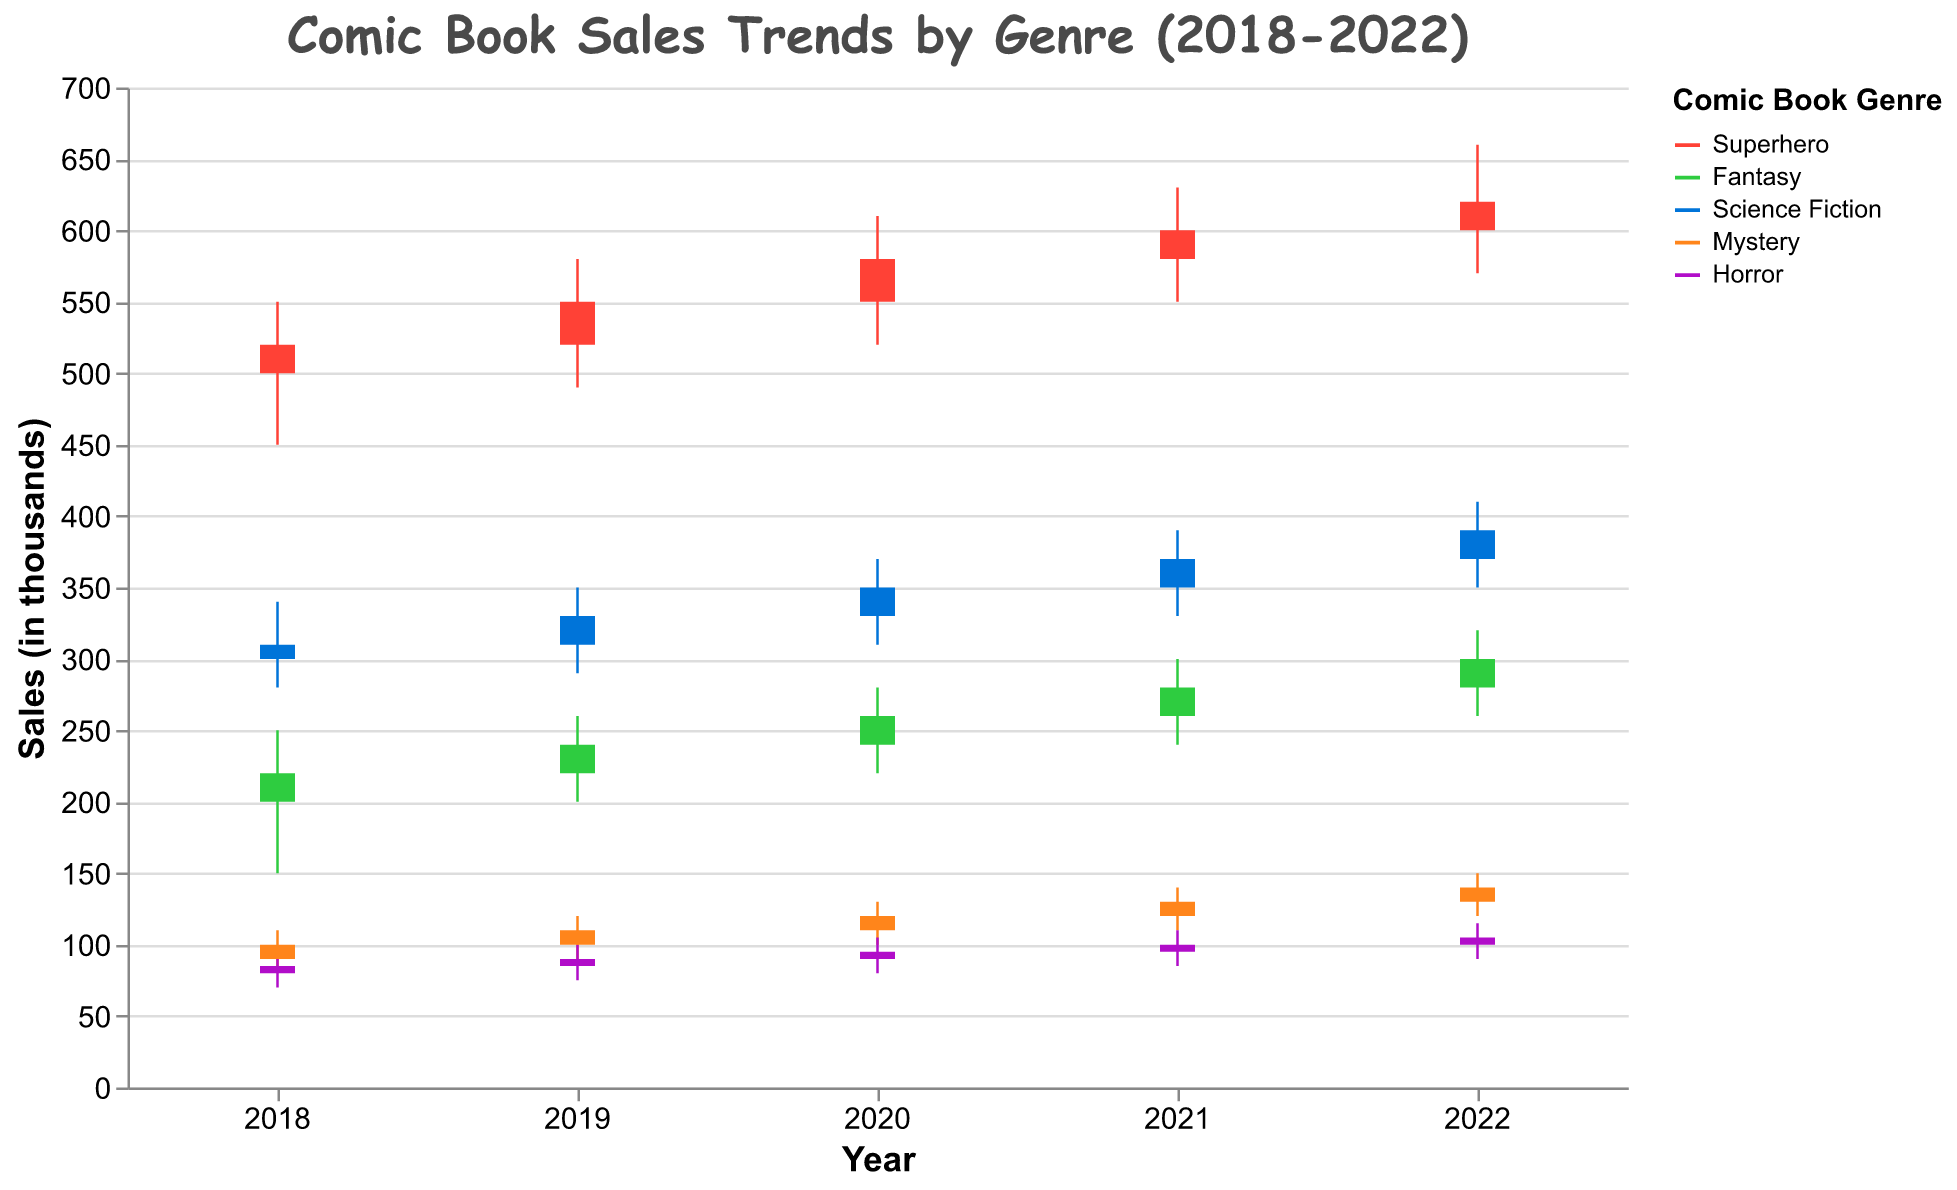What is the title of the figure? The title of the figure is usually displayed at the top of the chart and summarizes the primary focus of the data plot. Here, we see that the title is clearly labeled.
Answer: Comic Book Sales Trends by Genre (2018-2022) What are the genres displayed in the figure? The genres are indicated by the different colored bars and legend labels. By looking at the figure's color legend, we can identify each genre.
Answer: Superhero, Fantasy, Science Fiction, Mystery, Horror In which year did Science Fiction have the highest closing sales? Look at the height of the closing prices for Science Fiction across different years. The closing prices are marked by the endpoints of each bar. For Science Fiction, the year with the highest closing sales is 2022.
Answer: 2022 Which genre had the lowest high value in 2018? Compare the highest values (upper tip of the vertical line) across all genres for the year 2018. The genre with the lowest high value in 2018 is Horror.
Answer: Horror How did the sales trend for the Fantasy genre change from 2018 to 2022? Identify and compare the opening and closing sales values for the Fantasy genre from 2018 to 2022. This helps to see the trend over the years. The Fantasy genre shows an increase in both opening and closing values from 2018 to 2022.
Answer: Sales increased Which genre experienced the largest difference between its high and low values in 2020? Look at the high and low values for each genre in 2020. Calculate the difference for each genre and find the largest one. The Superhero genre experienced the largest difference (610 - 520 = 90).
Answer: Superhero Did the Mystery genre show an upward or downward trend in closing sales over the years? Compare the closing sales values for the Mystery genre from 2018 to 2022. Observing whether these values generally increase or decrease will indicate the trend. The closing sales for Mystery increased from 100 in 2018 to 140 in 2022, showing an upward trend.
Answer: Upward Which genre showed the smallest range between the high and low values in 2021? Look at the high and low values for each genre in 2021 and calculate the range (high - low). Find which genre has the smallest range. For 2021, the Horror genre has the smallest range with a difference of 25 (110 - 85 = 25).
Answer: Horror What is the average closing value of Superhero genre from 2018 to 2022? Identify the closing values of the Superhero genre for each year from 2018 to 2022. Add these values together and divide by the number of years to find the average. The average is (520 + 550 + 580 + 600 + 620) / 5 = 574.
Answer: 574 